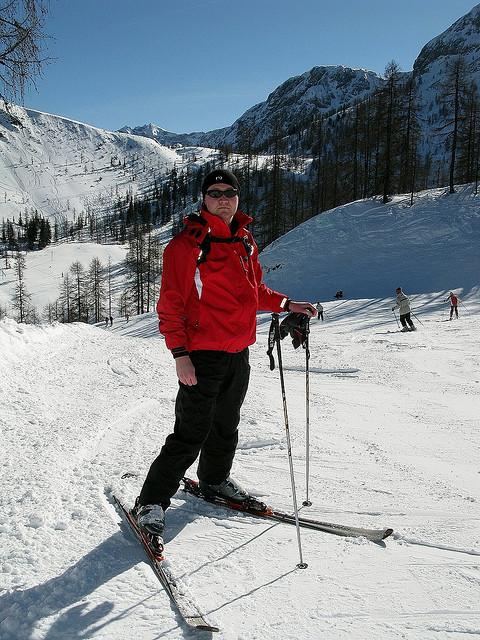What color jacket is he wearing?
Keep it brief. Red. Is it a sunny day?
Answer briefly. Yes. Are the man's skis parallel in this picture?
Answer briefly. No. 